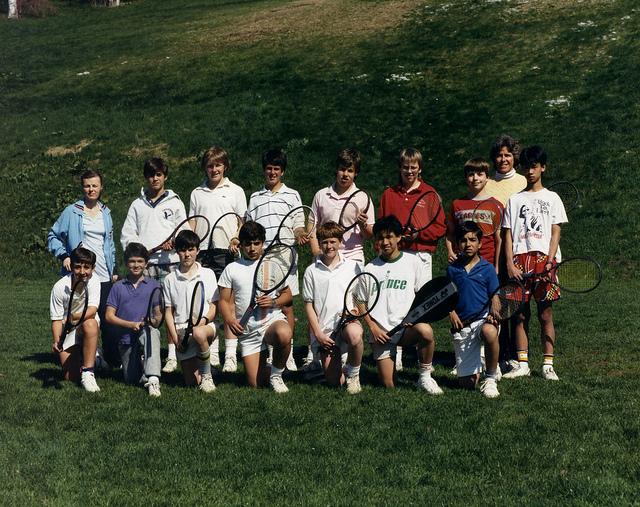What color of shoes is everyone wearing?
Write a very short answer. White. Is this a tennis team?
Concise answer only. Yes. What sport are they playing?
Give a very brief answer. Tennis. Are all the boys wearing the same color blazer?
Answer briefly. No. What sport equipment are the boys holding?
Write a very short answer. Tennis rackets. What are they holding in their hands?
Be succinct. Rackets. How many people are sitting down?
Concise answer only. 0. 